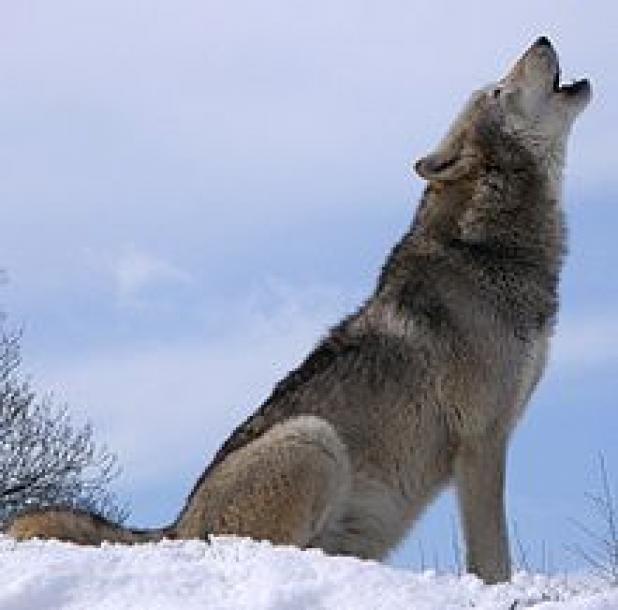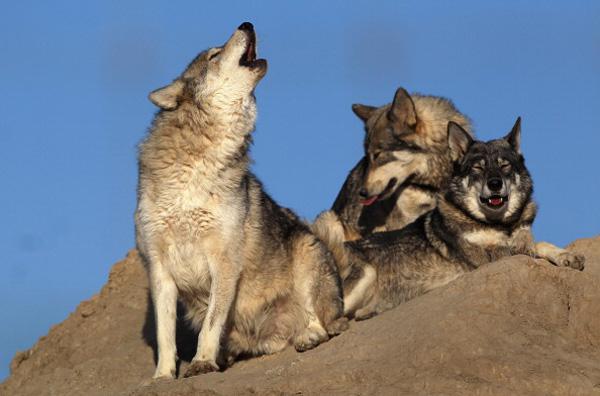The first image is the image on the left, the second image is the image on the right. Evaluate the accuracy of this statement regarding the images: "The combined images contain four wolves, including two adult wolves sitting upright with heads lifted, eyes shut, and mouths open in a howling pose.". Is it true? Answer yes or no. Yes. The first image is the image on the left, the second image is the image on the right. For the images displayed, is the sentence "There are two wolves in each image." factually correct? Answer yes or no. No. 